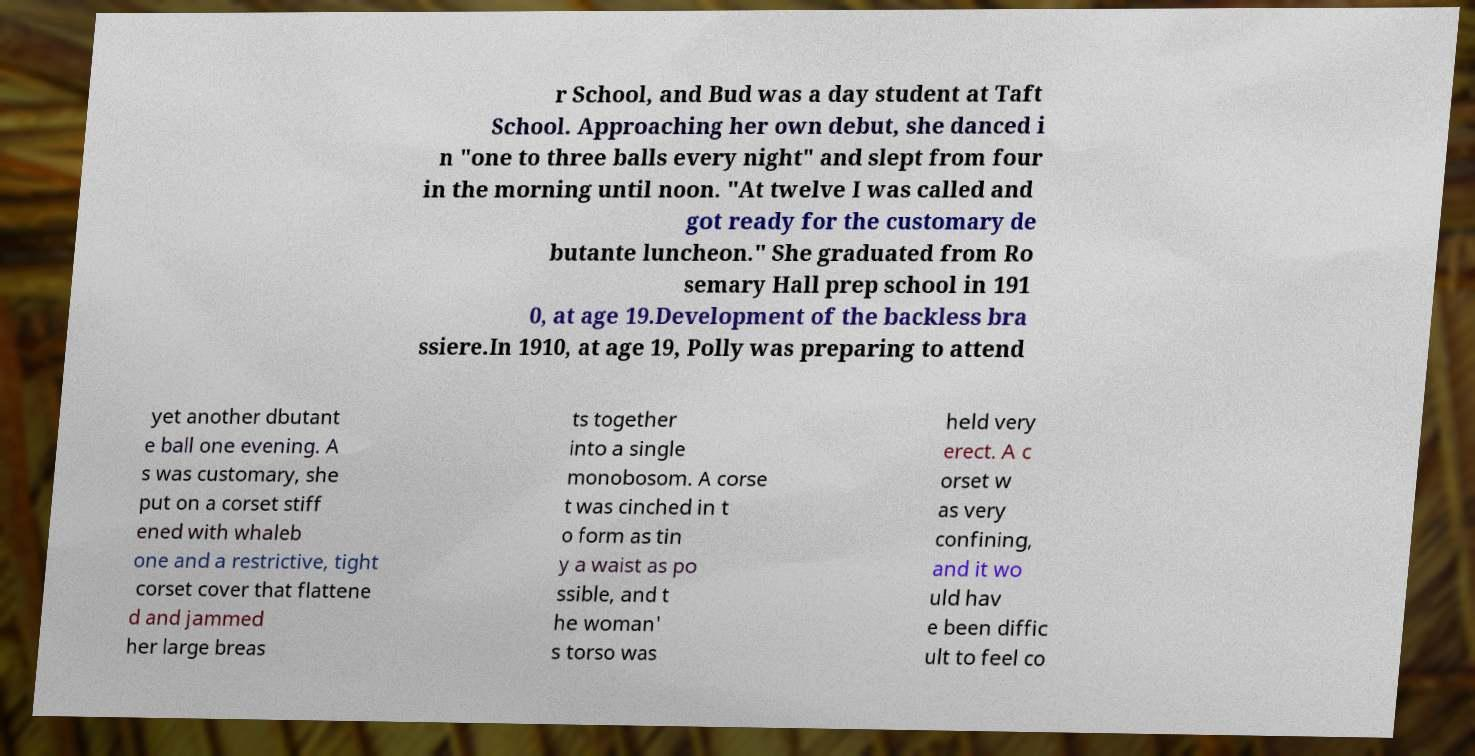There's text embedded in this image that I need extracted. Can you transcribe it verbatim? r School, and Bud was a day student at Taft School. Approaching her own debut, she danced i n "one to three balls every night" and slept from four in the morning until noon. "At twelve I was called and got ready for the customary de butante luncheon." She graduated from Ro semary Hall prep school in 191 0, at age 19.Development of the backless bra ssiere.In 1910, at age 19, Polly was preparing to attend yet another dbutant e ball one evening. A s was customary, she put on a corset stiff ened with whaleb one and a restrictive, tight corset cover that flattene d and jammed her large breas ts together into a single monobosom. A corse t was cinched in t o form as tin y a waist as po ssible, and t he woman' s torso was held very erect. A c orset w as very confining, and it wo uld hav e been diffic ult to feel co 